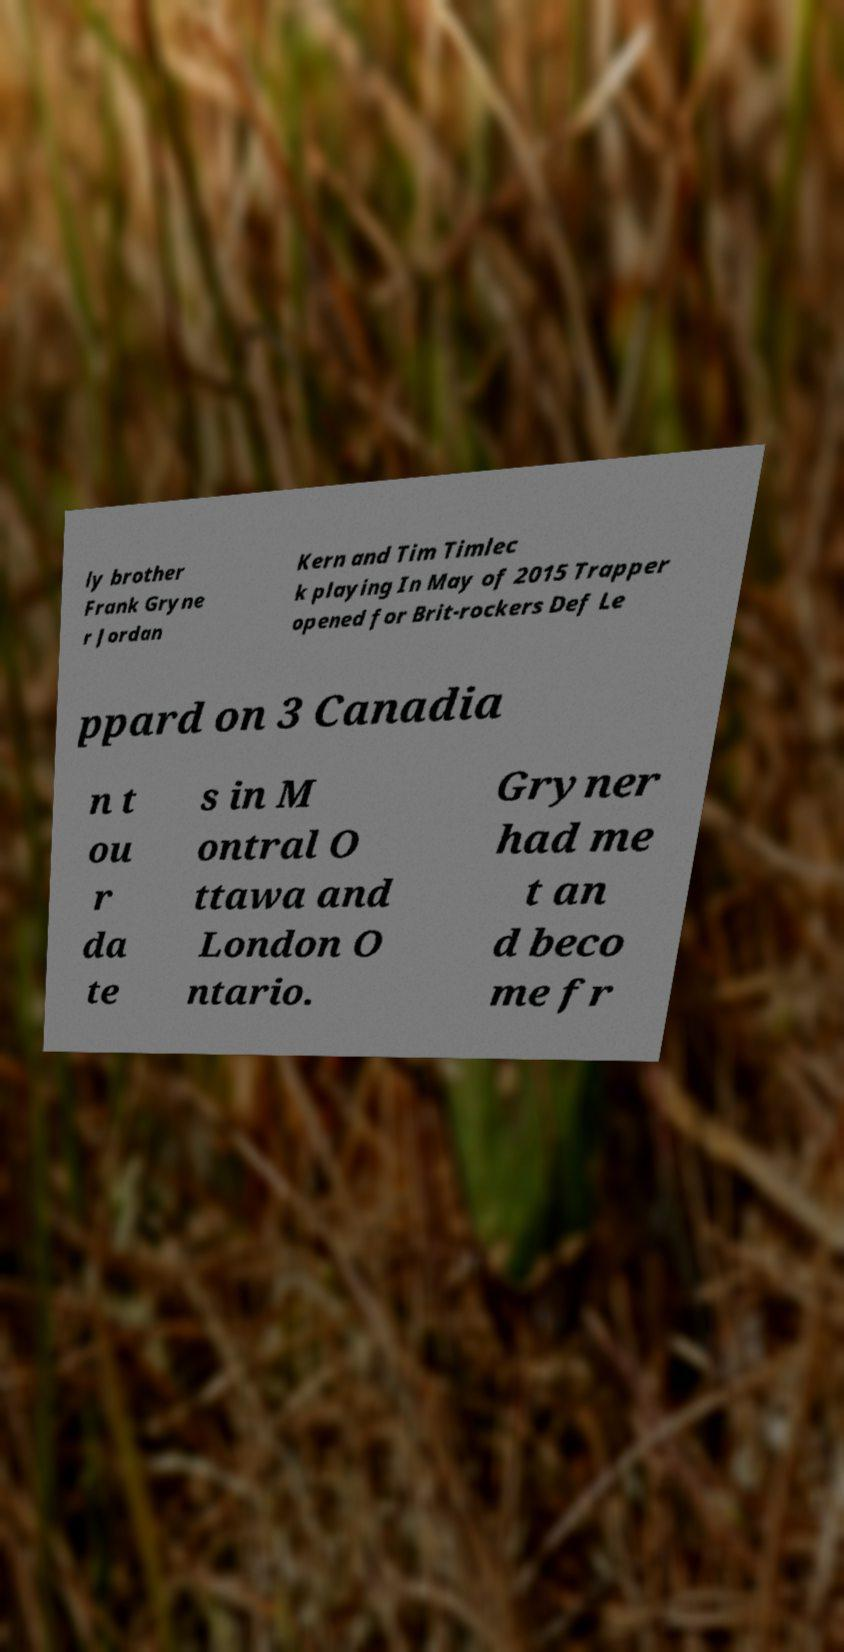Please identify and transcribe the text found in this image. ly brother Frank Gryne r Jordan Kern and Tim Timlec k playing In May of 2015 Trapper opened for Brit-rockers Def Le ppard on 3 Canadia n t ou r da te s in M ontral O ttawa and London O ntario. Gryner had me t an d beco me fr 